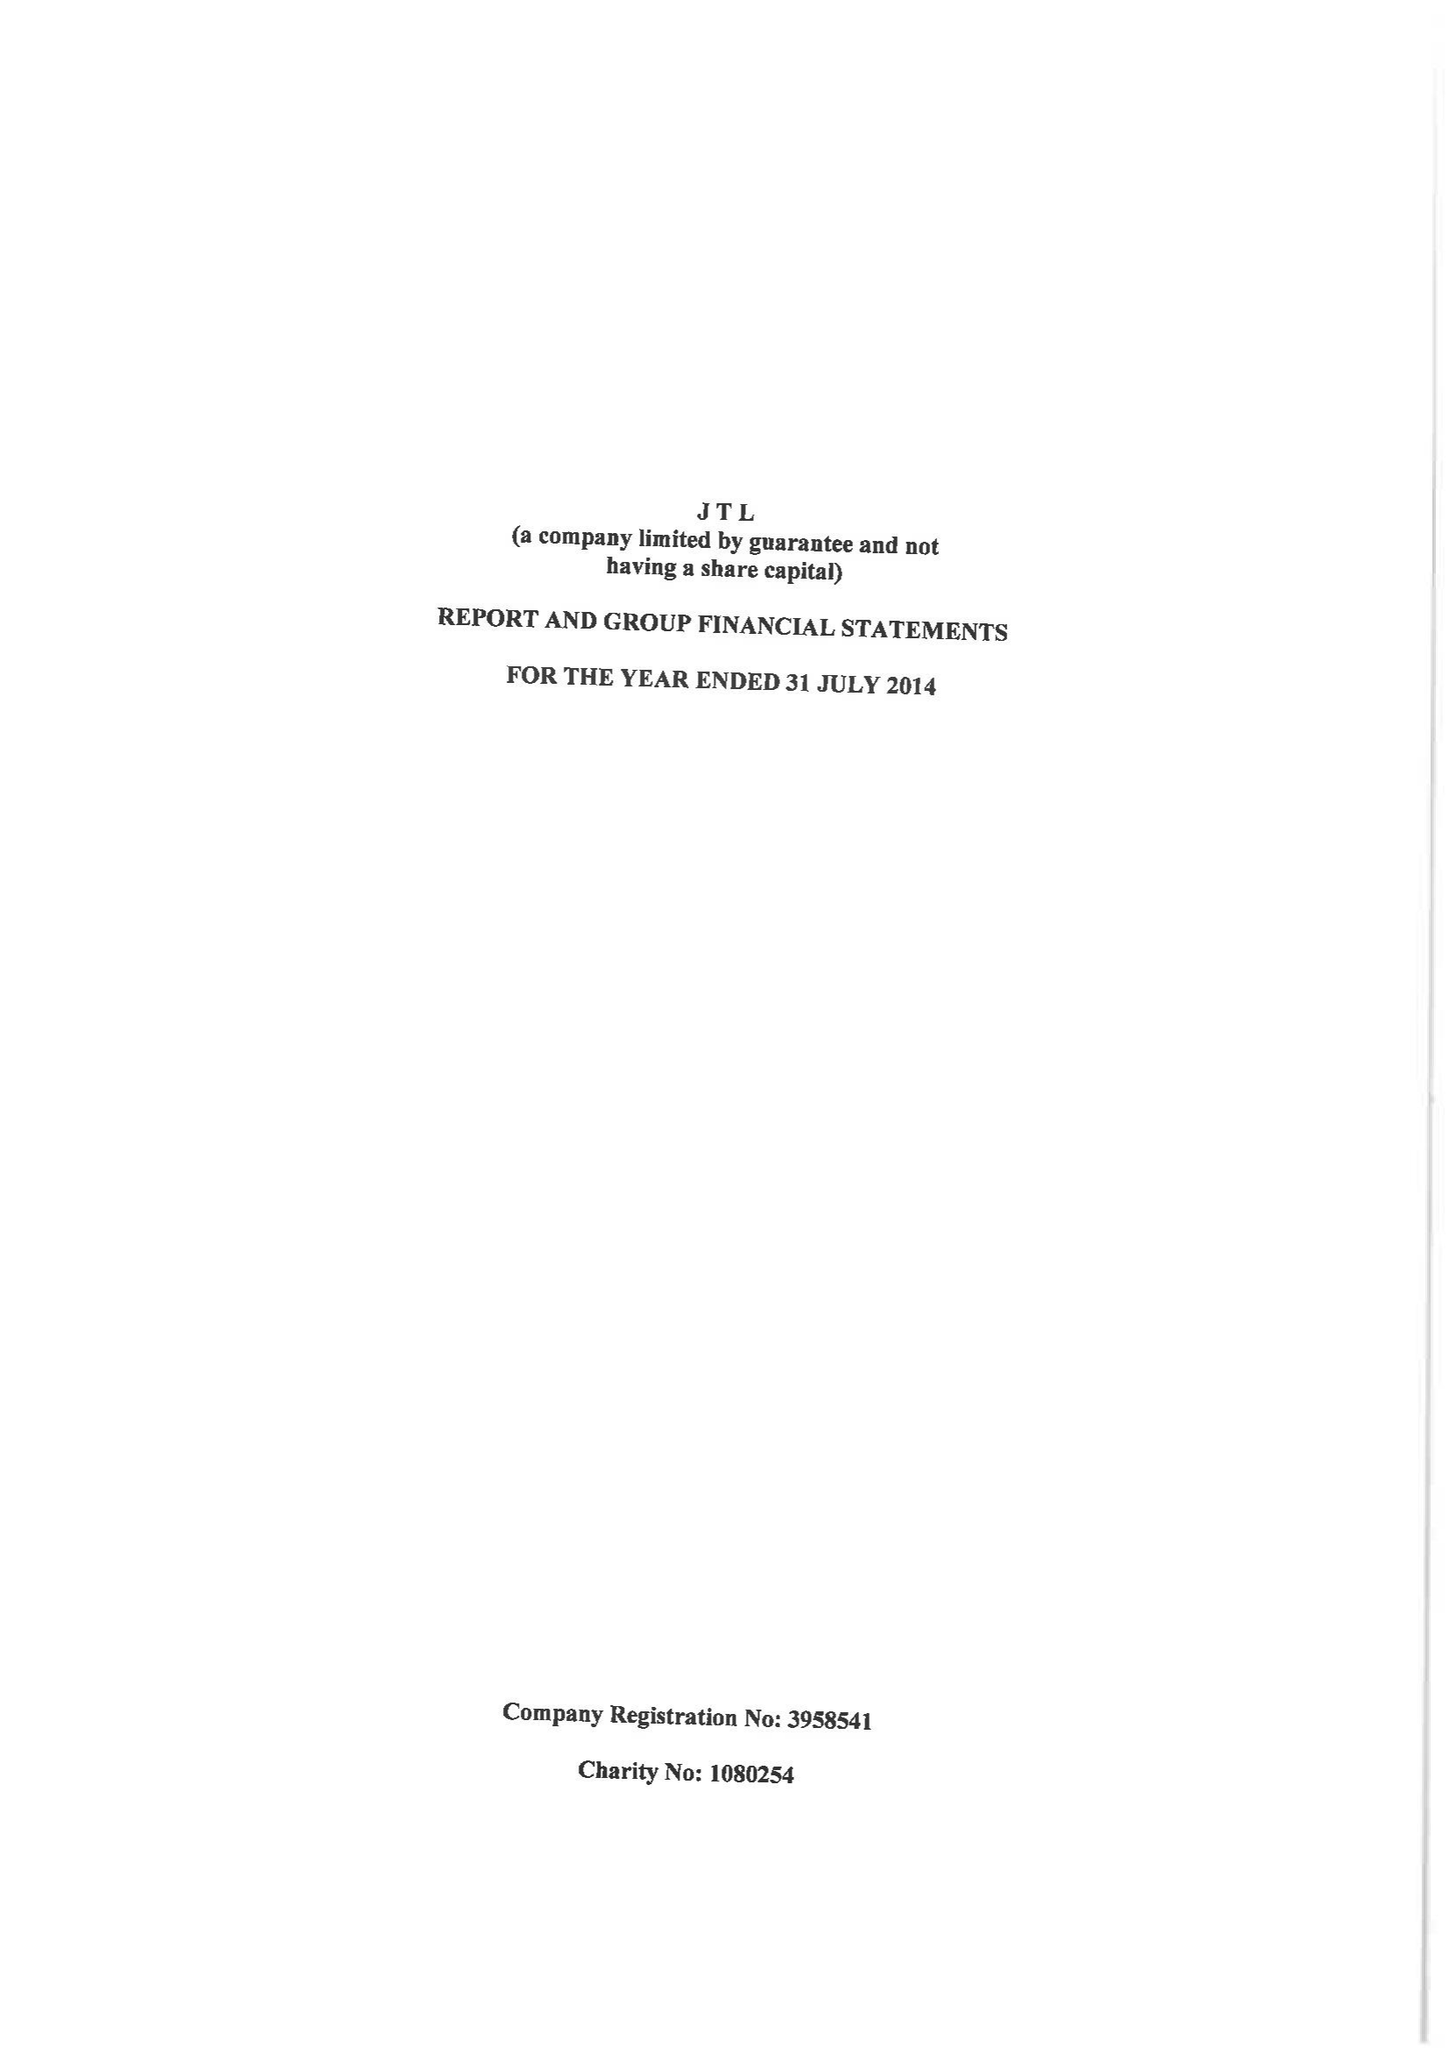What is the value for the address__post_town?
Answer the question using a single word or phrase. ORPINGTON 